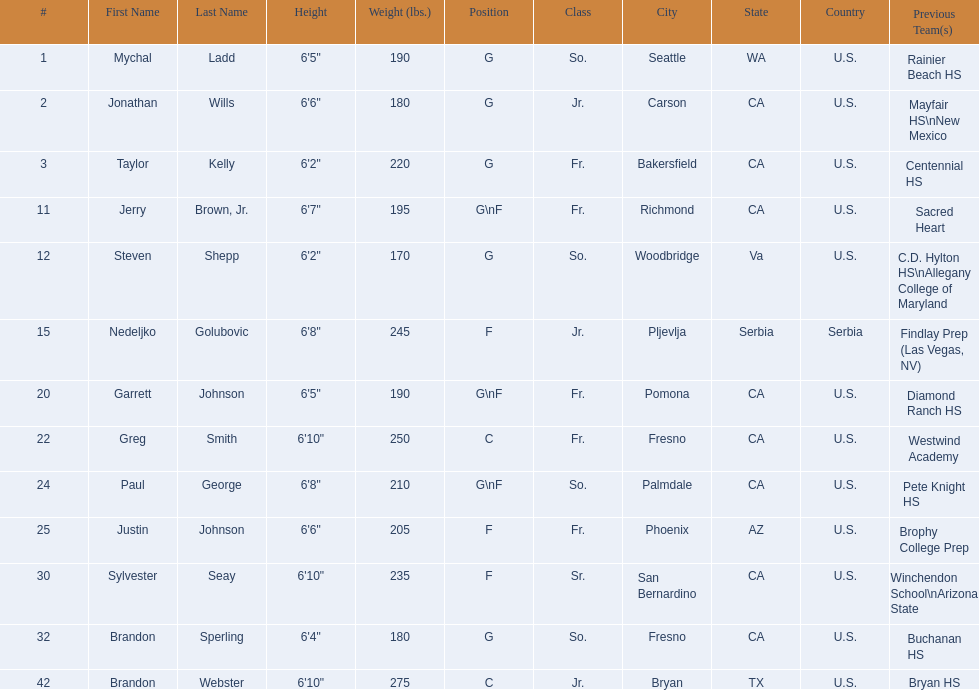Who played during the 2009-10 fresno state bulldogs men's basketball team? Mychal Ladd, Jonathan Wills, Taylor Kelly, Jerry Brown, Jr., Steven Shepp, Nedeljko Golubovic, Garrett Johnson, Greg Smith, Paul George, Justin Johnson, Sylvester Seay, Brandon Sperling, Brandon Webster. What was the position of each player? G, G, G, G\nF, G, F, G\nF, C, G\nF, F, F, G, C. And how tall were they? 6'5", 6'6", 6'2", 6'7", 6'2", 6'8", 6'5", 6'10", 6'8", 6'6", 6'10", 6'4", 6'10". Of these players, who was the shortest forward player? Justin Johnson. 